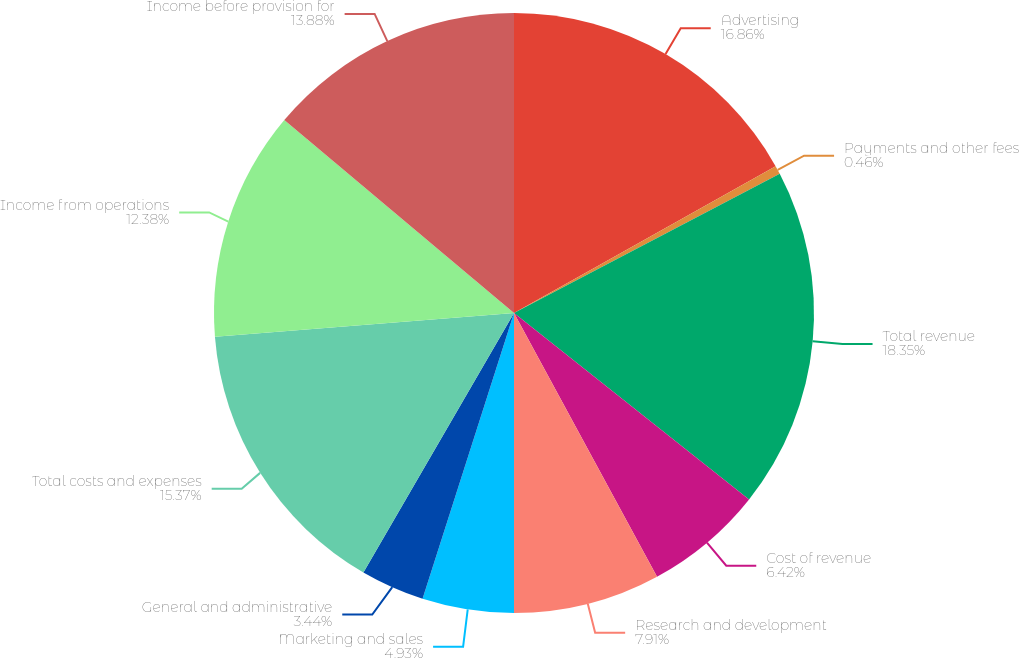<chart> <loc_0><loc_0><loc_500><loc_500><pie_chart><fcel>Advertising<fcel>Payments and other fees<fcel>Total revenue<fcel>Cost of revenue<fcel>Research and development<fcel>Marketing and sales<fcel>General and administrative<fcel>Total costs and expenses<fcel>Income from operations<fcel>Income before provision for<nl><fcel>16.86%<fcel>0.46%<fcel>18.35%<fcel>6.42%<fcel>7.91%<fcel>4.93%<fcel>3.44%<fcel>15.37%<fcel>12.38%<fcel>13.88%<nl></chart> 